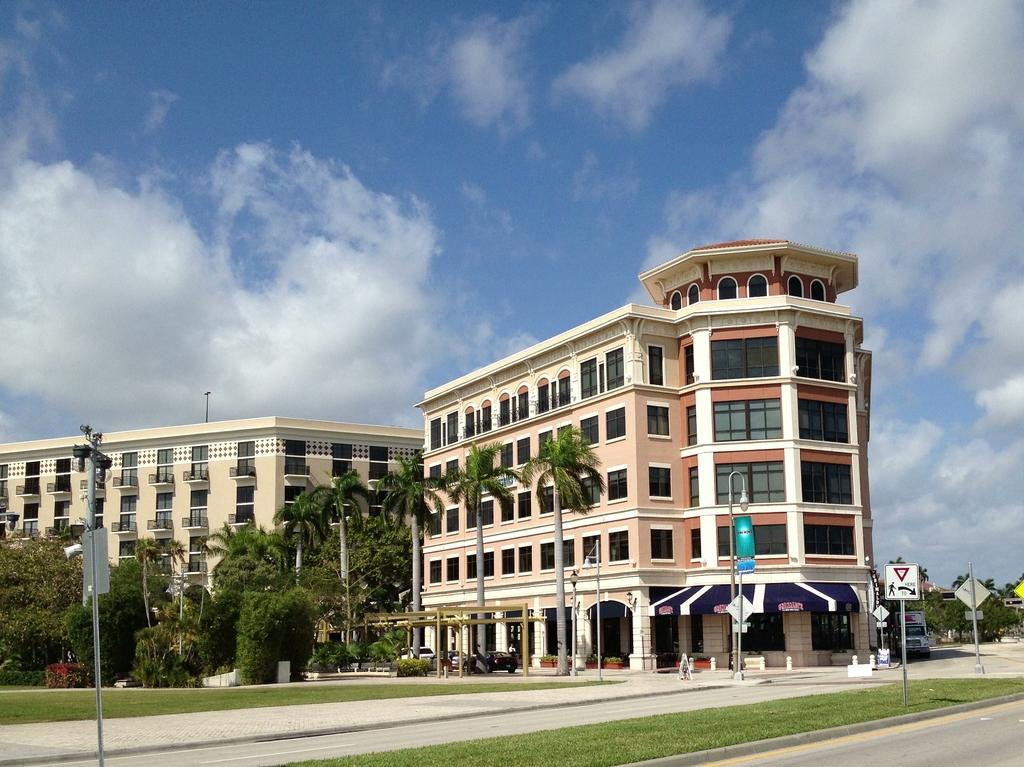What is attached to the poles in the image? There are boards and lights attached to poles in the image. What type of terrain is visible in the image? There is grass visible in the image. What types of man-made structures can be seen in the image? Vehicles, buildings, and poles with lights and boards are present in the image. What type of vegetation is visible in the image? Trees and plants are visible in the image. What can be seen in the background of the image? The sky with clouds is visible in the background of the image. Where is the throne located in the image? There is no throne present in the image. What type of spot is visible on the grass in the image? There is no specific spot mentioned or visible on the grass in the image. 